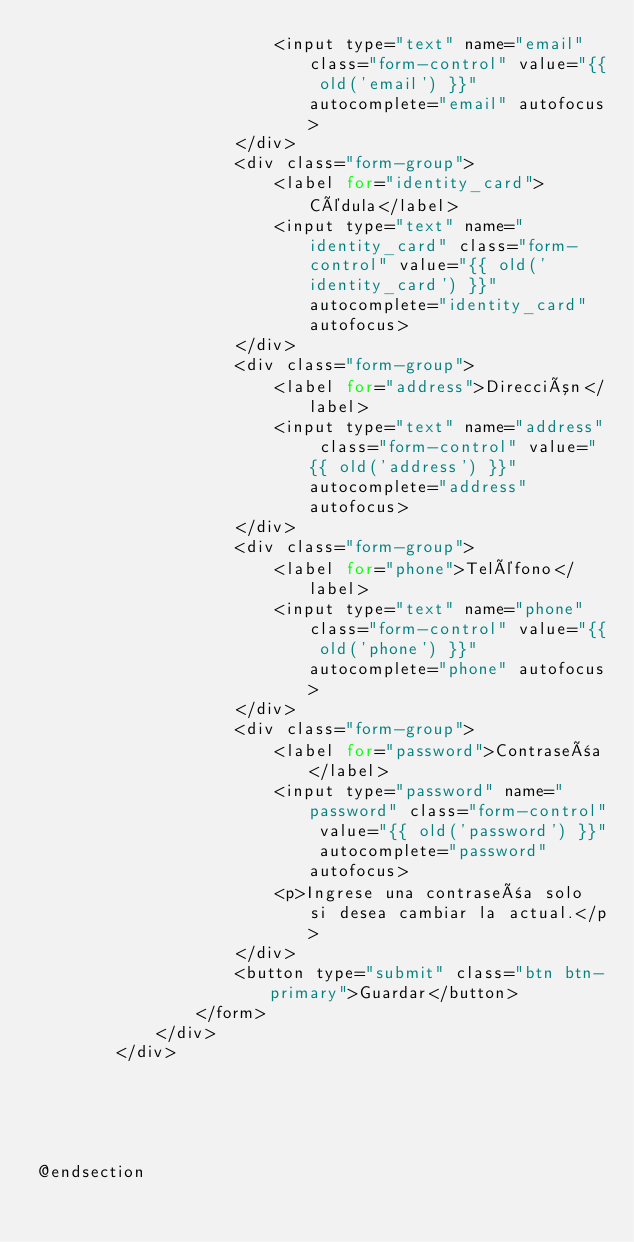Convert code to text. <code><loc_0><loc_0><loc_500><loc_500><_PHP_>                        <input type="text" name="email" class="form-control" value="{{ old('email') }}"  autocomplete="email" autofocus>
                    </div>
                    <div class="form-group">
                        <label for="identity_card"> Cédula</label>
                        <input type="text" name="identity_card" class="form-control" value="{{ old('identity_card') }}"  autocomplete="identity_card" autofocus>
                    </div>
                    <div class="form-group">
                        <label for="address">Dirección</label>
                        <input type="text" name="address" class="form-control" value="{{ old('address') }}"  autocomplete="address" autofocus>
                    </div>
                    <div class="form-group">
                        <label for="phone">Teléfono</label>
                        <input type="text" name="phone" class="form-control" value="{{ old('phone') }}"  autocomplete="phone" autofocus>
                    </div>
                    <div class="form-group">
                        <label for="password">Contraseña</label>
                        <input type="password" name="password" class="form-control" value="{{ old('password') }}" autocomplete="password" autofocus>
                        <p>Ingrese una contraseña solo si desea cambiar la actual.</p>
                    </div>                    
                    <button type="submit" class="btn btn-primary">Guardar</button>
                </form>
            </div>
        </div>
            




@endsection
</code> 